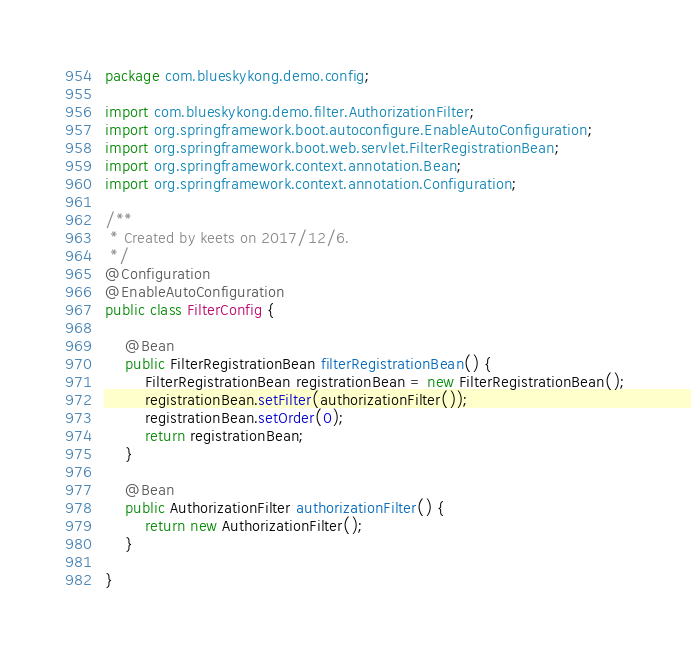<code> <loc_0><loc_0><loc_500><loc_500><_Java_>package com.blueskykong.demo.config;

import com.blueskykong.demo.filter.AuthorizationFilter;
import org.springframework.boot.autoconfigure.EnableAutoConfiguration;
import org.springframework.boot.web.servlet.FilterRegistrationBean;
import org.springframework.context.annotation.Bean;
import org.springframework.context.annotation.Configuration;

/**
 * Created by keets on 2017/12/6.
 */
@Configuration
@EnableAutoConfiguration
public class FilterConfig {

    @Bean
    public FilterRegistrationBean filterRegistrationBean() {
        FilterRegistrationBean registrationBean = new FilterRegistrationBean();
        registrationBean.setFilter(authorizationFilter());
        registrationBean.setOrder(0);
        return registrationBean;
    }

    @Bean
    public AuthorizationFilter authorizationFilter() {
        return new AuthorizationFilter();
    }

}
</code> 